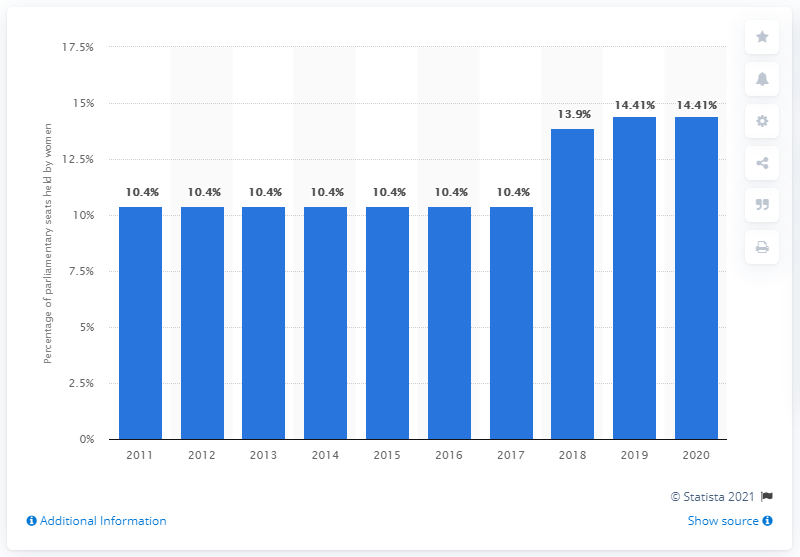Highlight a few significant elements in this photo. In 2018, Malaysia made significant progress in increasing the share of women in ministerial positions. The mode value for all the bars is 10.4. The median and minimum of women seats percent across all years are different values, with the median being 1.16 and the minimum being 0. 